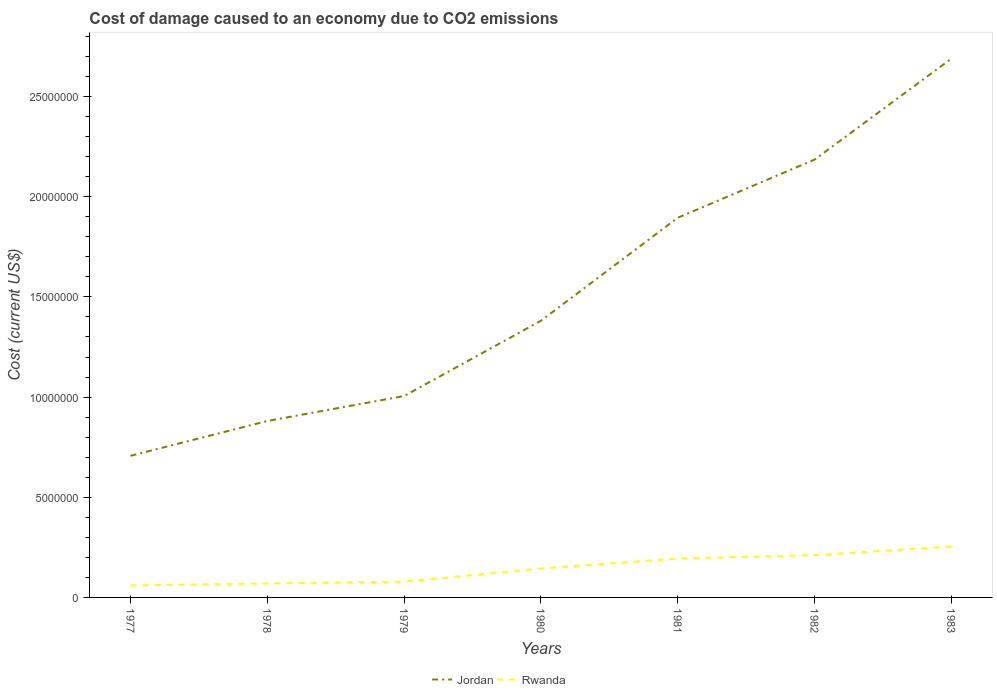Does the line corresponding to Rwanda intersect with the line corresponding to Jordan?
Your answer should be compact. No. Across all years, what is the maximum cost of damage caused due to CO2 emissisons in Rwanda?
Your response must be concise. 5.98e+05. In which year was the cost of damage caused due to CO2 emissisons in Rwanda maximum?
Keep it short and to the point. 1977. What is the total cost of damage caused due to CO2 emissisons in Jordan in the graph?
Your answer should be compact. -8.90e+06. What is the difference between the highest and the second highest cost of damage caused due to CO2 emissisons in Jordan?
Offer a terse response. 1.98e+07. Is the cost of damage caused due to CO2 emissisons in Rwanda strictly greater than the cost of damage caused due to CO2 emissisons in Jordan over the years?
Offer a terse response. Yes. How many lines are there?
Ensure brevity in your answer.  2. Does the graph contain grids?
Make the answer very short. No. How many legend labels are there?
Keep it short and to the point. 2. What is the title of the graph?
Make the answer very short. Cost of damage caused to an economy due to CO2 emissions. Does "Finland" appear as one of the legend labels in the graph?
Your answer should be compact. No. What is the label or title of the X-axis?
Provide a short and direct response. Years. What is the label or title of the Y-axis?
Your answer should be compact. Cost (current US$). What is the Cost (current US$) in Jordan in 1977?
Offer a very short reply. 7.07e+06. What is the Cost (current US$) in Rwanda in 1977?
Your answer should be very brief. 5.98e+05. What is the Cost (current US$) in Jordan in 1978?
Your response must be concise. 8.81e+06. What is the Cost (current US$) in Rwanda in 1978?
Your answer should be very brief. 7.01e+05. What is the Cost (current US$) of Jordan in 1979?
Your answer should be very brief. 1.01e+07. What is the Cost (current US$) in Rwanda in 1979?
Provide a succinct answer. 7.87e+05. What is the Cost (current US$) in Jordan in 1980?
Your answer should be very brief. 1.38e+07. What is the Cost (current US$) in Rwanda in 1980?
Keep it short and to the point. 1.45e+06. What is the Cost (current US$) of Jordan in 1981?
Provide a short and direct response. 1.90e+07. What is the Cost (current US$) in Rwanda in 1981?
Provide a succinct answer. 1.94e+06. What is the Cost (current US$) of Jordan in 1982?
Offer a very short reply. 2.19e+07. What is the Cost (current US$) in Rwanda in 1982?
Your response must be concise. 2.11e+06. What is the Cost (current US$) in Jordan in 1983?
Your response must be concise. 2.69e+07. What is the Cost (current US$) of Rwanda in 1983?
Your answer should be very brief. 2.54e+06. Across all years, what is the maximum Cost (current US$) of Jordan?
Offer a terse response. 2.69e+07. Across all years, what is the maximum Cost (current US$) in Rwanda?
Provide a succinct answer. 2.54e+06. Across all years, what is the minimum Cost (current US$) in Jordan?
Your answer should be compact. 7.07e+06. Across all years, what is the minimum Cost (current US$) of Rwanda?
Ensure brevity in your answer.  5.98e+05. What is the total Cost (current US$) of Jordan in the graph?
Provide a succinct answer. 1.07e+08. What is the total Cost (current US$) in Rwanda in the graph?
Your answer should be compact. 1.01e+07. What is the difference between the Cost (current US$) in Jordan in 1977 and that in 1978?
Your answer should be very brief. -1.74e+06. What is the difference between the Cost (current US$) in Rwanda in 1977 and that in 1978?
Provide a short and direct response. -1.03e+05. What is the difference between the Cost (current US$) in Jordan in 1977 and that in 1979?
Provide a succinct answer. -2.99e+06. What is the difference between the Cost (current US$) of Rwanda in 1977 and that in 1979?
Your response must be concise. -1.89e+05. What is the difference between the Cost (current US$) of Jordan in 1977 and that in 1980?
Give a very brief answer. -6.74e+06. What is the difference between the Cost (current US$) of Rwanda in 1977 and that in 1980?
Offer a terse response. -8.49e+05. What is the difference between the Cost (current US$) of Jordan in 1977 and that in 1981?
Give a very brief answer. -1.19e+07. What is the difference between the Cost (current US$) of Rwanda in 1977 and that in 1981?
Offer a terse response. -1.35e+06. What is the difference between the Cost (current US$) of Jordan in 1977 and that in 1982?
Offer a terse response. -1.48e+07. What is the difference between the Cost (current US$) in Rwanda in 1977 and that in 1982?
Your answer should be compact. -1.52e+06. What is the difference between the Cost (current US$) in Jordan in 1977 and that in 1983?
Offer a terse response. -1.98e+07. What is the difference between the Cost (current US$) in Rwanda in 1977 and that in 1983?
Ensure brevity in your answer.  -1.95e+06. What is the difference between the Cost (current US$) of Jordan in 1978 and that in 1979?
Your answer should be very brief. -1.25e+06. What is the difference between the Cost (current US$) in Rwanda in 1978 and that in 1979?
Your answer should be very brief. -8.62e+04. What is the difference between the Cost (current US$) in Jordan in 1978 and that in 1980?
Your answer should be very brief. -5.00e+06. What is the difference between the Cost (current US$) in Rwanda in 1978 and that in 1980?
Provide a succinct answer. -7.46e+05. What is the difference between the Cost (current US$) of Jordan in 1978 and that in 1981?
Make the answer very short. -1.01e+07. What is the difference between the Cost (current US$) in Rwanda in 1978 and that in 1981?
Your answer should be very brief. -1.24e+06. What is the difference between the Cost (current US$) in Jordan in 1978 and that in 1982?
Provide a short and direct response. -1.30e+07. What is the difference between the Cost (current US$) in Rwanda in 1978 and that in 1982?
Offer a very short reply. -1.41e+06. What is the difference between the Cost (current US$) in Jordan in 1978 and that in 1983?
Your answer should be very brief. -1.81e+07. What is the difference between the Cost (current US$) in Rwanda in 1978 and that in 1983?
Your response must be concise. -1.84e+06. What is the difference between the Cost (current US$) of Jordan in 1979 and that in 1980?
Give a very brief answer. -3.76e+06. What is the difference between the Cost (current US$) of Rwanda in 1979 and that in 1980?
Your answer should be compact. -6.60e+05. What is the difference between the Cost (current US$) in Jordan in 1979 and that in 1981?
Provide a succinct answer. -8.90e+06. What is the difference between the Cost (current US$) of Rwanda in 1979 and that in 1981?
Make the answer very short. -1.16e+06. What is the difference between the Cost (current US$) in Jordan in 1979 and that in 1982?
Offer a terse response. -1.18e+07. What is the difference between the Cost (current US$) of Rwanda in 1979 and that in 1982?
Make the answer very short. -1.33e+06. What is the difference between the Cost (current US$) of Jordan in 1979 and that in 1983?
Keep it short and to the point. -1.68e+07. What is the difference between the Cost (current US$) in Rwanda in 1979 and that in 1983?
Your response must be concise. -1.76e+06. What is the difference between the Cost (current US$) of Jordan in 1980 and that in 1981?
Offer a very short reply. -5.14e+06. What is the difference between the Cost (current US$) in Rwanda in 1980 and that in 1981?
Provide a short and direct response. -4.97e+05. What is the difference between the Cost (current US$) in Jordan in 1980 and that in 1982?
Offer a terse response. -8.04e+06. What is the difference between the Cost (current US$) in Rwanda in 1980 and that in 1982?
Make the answer very short. -6.68e+05. What is the difference between the Cost (current US$) in Jordan in 1980 and that in 1983?
Provide a succinct answer. -1.31e+07. What is the difference between the Cost (current US$) in Rwanda in 1980 and that in 1983?
Your answer should be compact. -1.10e+06. What is the difference between the Cost (current US$) in Jordan in 1981 and that in 1982?
Your answer should be very brief. -2.90e+06. What is the difference between the Cost (current US$) of Rwanda in 1981 and that in 1982?
Provide a short and direct response. -1.70e+05. What is the difference between the Cost (current US$) in Jordan in 1981 and that in 1983?
Offer a terse response. -7.94e+06. What is the difference between the Cost (current US$) in Rwanda in 1981 and that in 1983?
Ensure brevity in your answer.  -6.01e+05. What is the difference between the Cost (current US$) of Jordan in 1982 and that in 1983?
Give a very brief answer. -5.04e+06. What is the difference between the Cost (current US$) in Rwanda in 1982 and that in 1983?
Keep it short and to the point. -4.31e+05. What is the difference between the Cost (current US$) in Jordan in 1977 and the Cost (current US$) in Rwanda in 1978?
Ensure brevity in your answer.  6.37e+06. What is the difference between the Cost (current US$) of Jordan in 1977 and the Cost (current US$) of Rwanda in 1979?
Offer a terse response. 6.28e+06. What is the difference between the Cost (current US$) in Jordan in 1977 and the Cost (current US$) in Rwanda in 1980?
Make the answer very short. 5.62e+06. What is the difference between the Cost (current US$) in Jordan in 1977 and the Cost (current US$) in Rwanda in 1981?
Make the answer very short. 5.13e+06. What is the difference between the Cost (current US$) of Jordan in 1977 and the Cost (current US$) of Rwanda in 1982?
Offer a terse response. 4.95e+06. What is the difference between the Cost (current US$) in Jordan in 1977 and the Cost (current US$) in Rwanda in 1983?
Offer a terse response. 4.52e+06. What is the difference between the Cost (current US$) of Jordan in 1978 and the Cost (current US$) of Rwanda in 1979?
Your answer should be compact. 8.02e+06. What is the difference between the Cost (current US$) of Jordan in 1978 and the Cost (current US$) of Rwanda in 1980?
Ensure brevity in your answer.  7.36e+06. What is the difference between the Cost (current US$) of Jordan in 1978 and the Cost (current US$) of Rwanda in 1981?
Offer a very short reply. 6.86e+06. What is the difference between the Cost (current US$) of Jordan in 1978 and the Cost (current US$) of Rwanda in 1982?
Make the answer very short. 6.69e+06. What is the difference between the Cost (current US$) in Jordan in 1978 and the Cost (current US$) in Rwanda in 1983?
Ensure brevity in your answer.  6.26e+06. What is the difference between the Cost (current US$) in Jordan in 1979 and the Cost (current US$) in Rwanda in 1980?
Keep it short and to the point. 8.61e+06. What is the difference between the Cost (current US$) of Jordan in 1979 and the Cost (current US$) of Rwanda in 1981?
Ensure brevity in your answer.  8.11e+06. What is the difference between the Cost (current US$) in Jordan in 1979 and the Cost (current US$) in Rwanda in 1982?
Provide a succinct answer. 7.94e+06. What is the difference between the Cost (current US$) in Jordan in 1979 and the Cost (current US$) in Rwanda in 1983?
Give a very brief answer. 7.51e+06. What is the difference between the Cost (current US$) in Jordan in 1980 and the Cost (current US$) in Rwanda in 1981?
Provide a short and direct response. 1.19e+07. What is the difference between the Cost (current US$) in Jordan in 1980 and the Cost (current US$) in Rwanda in 1982?
Your answer should be compact. 1.17e+07. What is the difference between the Cost (current US$) in Jordan in 1980 and the Cost (current US$) in Rwanda in 1983?
Keep it short and to the point. 1.13e+07. What is the difference between the Cost (current US$) of Jordan in 1981 and the Cost (current US$) of Rwanda in 1982?
Ensure brevity in your answer.  1.68e+07. What is the difference between the Cost (current US$) in Jordan in 1981 and the Cost (current US$) in Rwanda in 1983?
Make the answer very short. 1.64e+07. What is the difference between the Cost (current US$) of Jordan in 1982 and the Cost (current US$) of Rwanda in 1983?
Provide a succinct answer. 1.93e+07. What is the average Cost (current US$) in Jordan per year?
Offer a terse response. 1.53e+07. What is the average Cost (current US$) in Rwanda per year?
Your answer should be compact. 1.45e+06. In the year 1977, what is the difference between the Cost (current US$) of Jordan and Cost (current US$) of Rwanda?
Provide a short and direct response. 6.47e+06. In the year 1978, what is the difference between the Cost (current US$) in Jordan and Cost (current US$) in Rwanda?
Your response must be concise. 8.11e+06. In the year 1979, what is the difference between the Cost (current US$) in Jordan and Cost (current US$) in Rwanda?
Provide a short and direct response. 9.27e+06. In the year 1980, what is the difference between the Cost (current US$) in Jordan and Cost (current US$) in Rwanda?
Your answer should be very brief. 1.24e+07. In the year 1981, what is the difference between the Cost (current US$) in Jordan and Cost (current US$) in Rwanda?
Give a very brief answer. 1.70e+07. In the year 1982, what is the difference between the Cost (current US$) in Jordan and Cost (current US$) in Rwanda?
Offer a very short reply. 1.97e+07. In the year 1983, what is the difference between the Cost (current US$) of Jordan and Cost (current US$) of Rwanda?
Your response must be concise. 2.44e+07. What is the ratio of the Cost (current US$) of Jordan in 1977 to that in 1978?
Offer a very short reply. 0.8. What is the ratio of the Cost (current US$) in Rwanda in 1977 to that in 1978?
Provide a succinct answer. 0.85. What is the ratio of the Cost (current US$) in Jordan in 1977 to that in 1979?
Make the answer very short. 0.7. What is the ratio of the Cost (current US$) of Rwanda in 1977 to that in 1979?
Give a very brief answer. 0.76. What is the ratio of the Cost (current US$) of Jordan in 1977 to that in 1980?
Keep it short and to the point. 0.51. What is the ratio of the Cost (current US$) in Rwanda in 1977 to that in 1980?
Give a very brief answer. 0.41. What is the ratio of the Cost (current US$) in Jordan in 1977 to that in 1981?
Offer a very short reply. 0.37. What is the ratio of the Cost (current US$) in Rwanda in 1977 to that in 1981?
Your response must be concise. 0.31. What is the ratio of the Cost (current US$) of Jordan in 1977 to that in 1982?
Your answer should be very brief. 0.32. What is the ratio of the Cost (current US$) of Rwanda in 1977 to that in 1982?
Make the answer very short. 0.28. What is the ratio of the Cost (current US$) of Jordan in 1977 to that in 1983?
Ensure brevity in your answer.  0.26. What is the ratio of the Cost (current US$) in Rwanda in 1977 to that in 1983?
Your answer should be very brief. 0.23. What is the ratio of the Cost (current US$) of Jordan in 1978 to that in 1979?
Offer a very short reply. 0.88. What is the ratio of the Cost (current US$) of Rwanda in 1978 to that in 1979?
Give a very brief answer. 0.89. What is the ratio of the Cost (current US$) in Jordan in 1978 to that in 1980?
Make the answer very short. 0.64. What is the ratio of the Cost (current US$) in Rwanda in 1978 to that in 1980?
Your answer should be very brief. 0.48. What is the ratio of the Cost (current US$) in Jordan in 1978 to that in 1981?
Your response must be concise. 0.46. What is the ratio of the Cost (current US$) in Rwanda in 1978 to that in 1981?
Provide a succinct answer. 0.36. What is the ratio of the Cost (current US$) in Jordan in 1978 to that in 1982?
Your response must be concise. 0.4. What is the ratio of the Cost (current US$) of Rwanda in 1978 to that in 1982?
Ensure brevity in your answer.  0.33. What is the ratio of the Cost (current US$) in Jordan in 1978 to that in 1983?
Ensure brevity in your answer.  0.33. What is the ratio of the Cost (current US$) of Rwanda in 1978 to that in 1983?
Offer a very short reply. 0.28. What is the ratio of the Cost (current US$) of Jordan in 1979 to that in 1980?
Make the answer very short. 0.73. What is the ratio of the Cost (current US$) in Rwanda in 1979 to that in 1980?
Provide a succinct answer. 0.54. What is the ratio of the Cost (current US$) in Jordan in 1979 to that in 1981?
Your answer should be very brief. 0.53. What is the ratio of the Cost (current US$) of Rwanda in 1979 to that in 1981?
Make the answer very short. 0.4. What is the ratio of the Cost (current US$) in Jordan in 1979 to that in 1982?
Your answer should be very brief. 0.46. What is the ratio of the Cost (current US$) in Rwanda in 1979 to that in 1982?
Your answer should be very brief. 0.37. What is the ratio of the Cost (current US$) in Jordan in 1979 to that in 1983?
Keep it short and to the point. 0.37. What is the ratio of the Cost (current US$) in Rwanda in 1979 to that in 1983?
Your answer should be compact. 0.31. What is the ratio of the Cost (current US$) of Jordan in 1980 to that in 1981?
Your answer should be very brief. 0.73. What is the ratio of the Cost (current US$) of Rwanda in 1980 to that in 1981?
Your response must be concise. 0.74. What is the ratio of the Cost (current US$) in Jordan in 1980 to that in 1982?
Your answer should be very brief. 0.63. What is the ratio of the Cost (current US$) in Rwanda in 1980 to that in 1982?
Provide a succinct answer. 0.68. What is the ratio of the Cost (current US$) in Jordan in 1980 to that in 1983?
Provide a succinct answer. 0.51. What is the ratio of the Cost (current US$) in Rwanda in 1980 to that in 1983?
Offer a very short reply. 0.57. What is the ratio of the Cost (current US$) in Jordan in 1981 to that in 1982?
Keep it short and to the point. 0.87. What is the ratio of the Cost (current US$) of Rwanda in 1981 to that in 1982?
Your answer should be very brief. 0.92. What is the ratio of the Cost (current US$) in Jordan in 1981 to that in 1983?
Your response must be concise. 0.7. What is the ratio of the Cost (current US$) in Rwanda in 1981 to that in 1983?
Give a very brief answer. 0.76. What is the ratio of the Cost (current US$) in Jordan in 1982 to that in 1983?
Provide a short and direct response. 0.81. What is the ratio of the Cost (current US$) of Rwanda in 1982 to that in 1983?
Keep it short and to the point. 0.83. What is the difference between the highest and the second highest Cost (current US$) in Jordan?
Ensure brevity in your answer.  5.04e+06. What is the difference between the highest and the second highest Cost (current US$) of Rwanda?
Make the answer very short. 4.31e+05. What is the difference between the highest and the lowest Cost (current US$) of Jordan?
Keep it short and to the point. 1.98e+07. What is the difference between the highest and the lowest Cost (current US$) of Rwanda?
Give a very brief answer. 1.95e+06. 